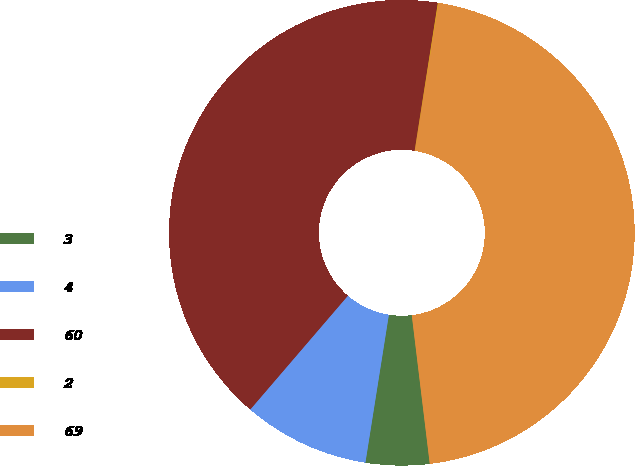<chart> <loc_0><loc_0><loc_500><loc_500><pie_chart><fcel>3<fcel>4<fcel>60<fcel>2<fcel>69<nl><fcel>4.42%<fcel>8.78%<fcel>41.19%<fcel>0.06%<fcel>45.55%<nl></chart> 